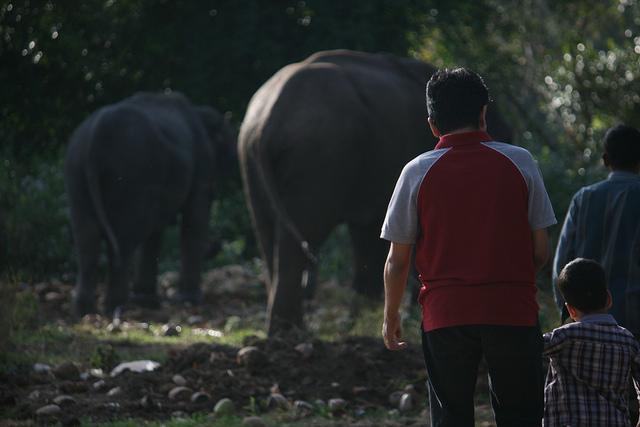Are these people following too close behind these elephants?
Answer briefly. Yes. Is the elephant in the water?
Concise answer only. No. Is this a town?
Write a very short answer. No. What kind of elephant is in this photo? Indian or African?
Be succinct. Indian. Is this a horse or elephant?
Short answer required. Elephant. What kind of animal is this?
Write a very short answer. Elephant. What part of the elephants do you see?
Concise answer only. Rear. Which elephant is partially in the sun?
Write a very short answer. Yes. 